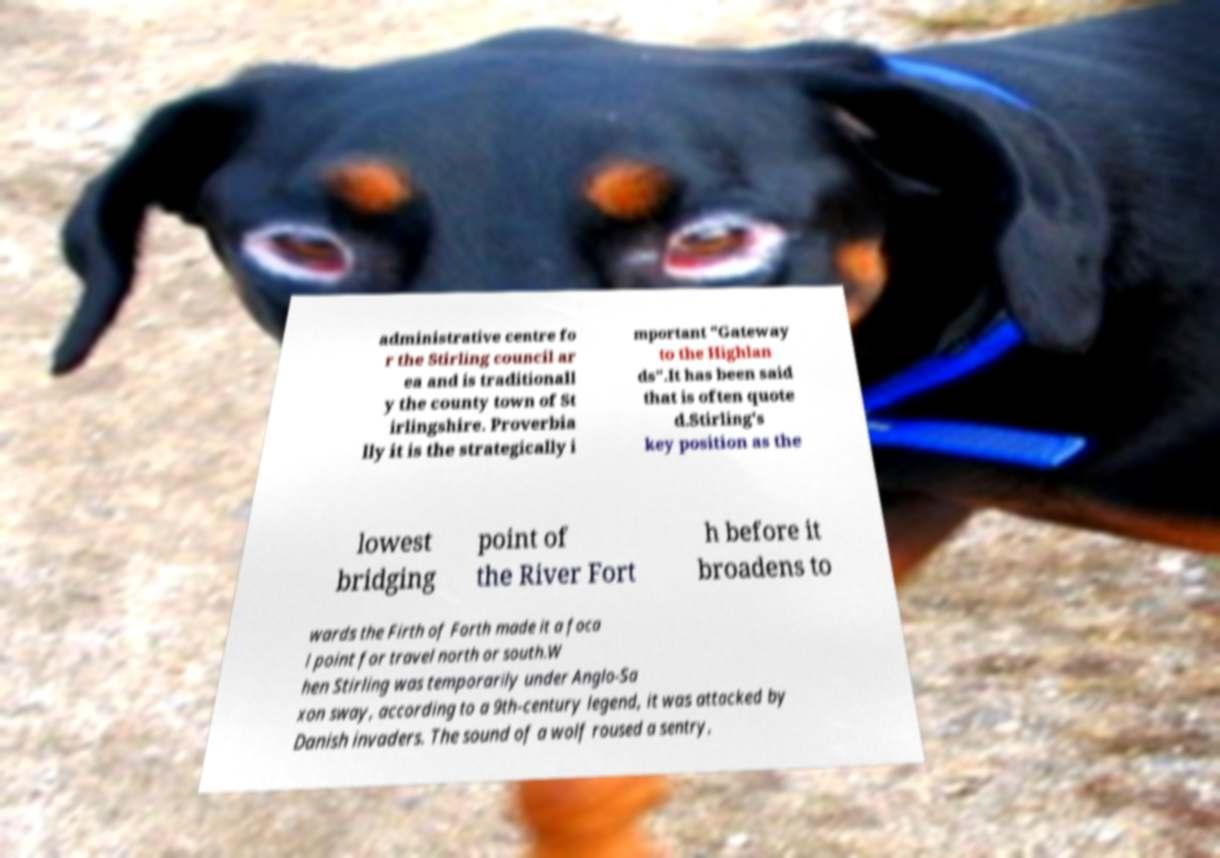There's text embedded in this image that I need extracted. Can you transcribe it verbatim? administrative centre fo r the Stirling council ar ea and is traditionall y the county town of St irlingshire. Proverbia lly it is the strategically i mportant "Gateway to the Highlan ds".It has been said that is often quote d.Stirling's key position as the lowest bridging point of the River Fort h before it broadens to wards the Firth of Forth made it a foca l point for travel north or south.W hen Stirling was temporarily under Anglo-Sa xon sway, according to a 9th-century legend, it was attacked by Danish invaders. The sound of a wolf roused a sentry, 